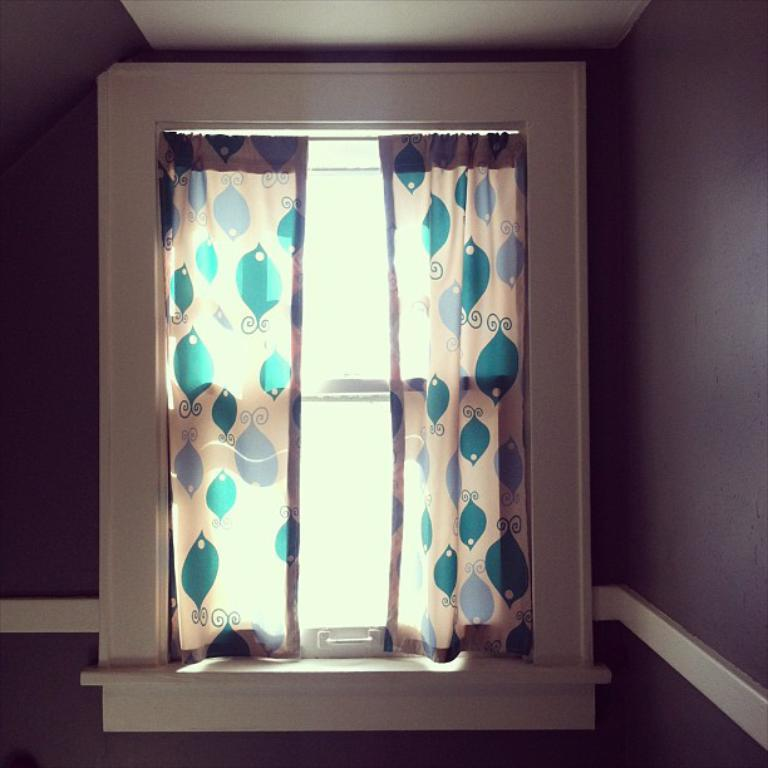What is located in the middle of the image? There is a window in the middle of the image. What can be found on the window in the image? The window has curtains on the wall. What type of beam can be seen supporting the dock in the image? There is no dock or beam present in the image; it only features a window with curtains on the wall. 